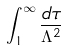<formula> <loc_0><loc_0><loc_500><loc_500>\int _ { 1 } ^ { \infty } \frac { d \tau } { \Lambda ^ { 2 } }</formula> 